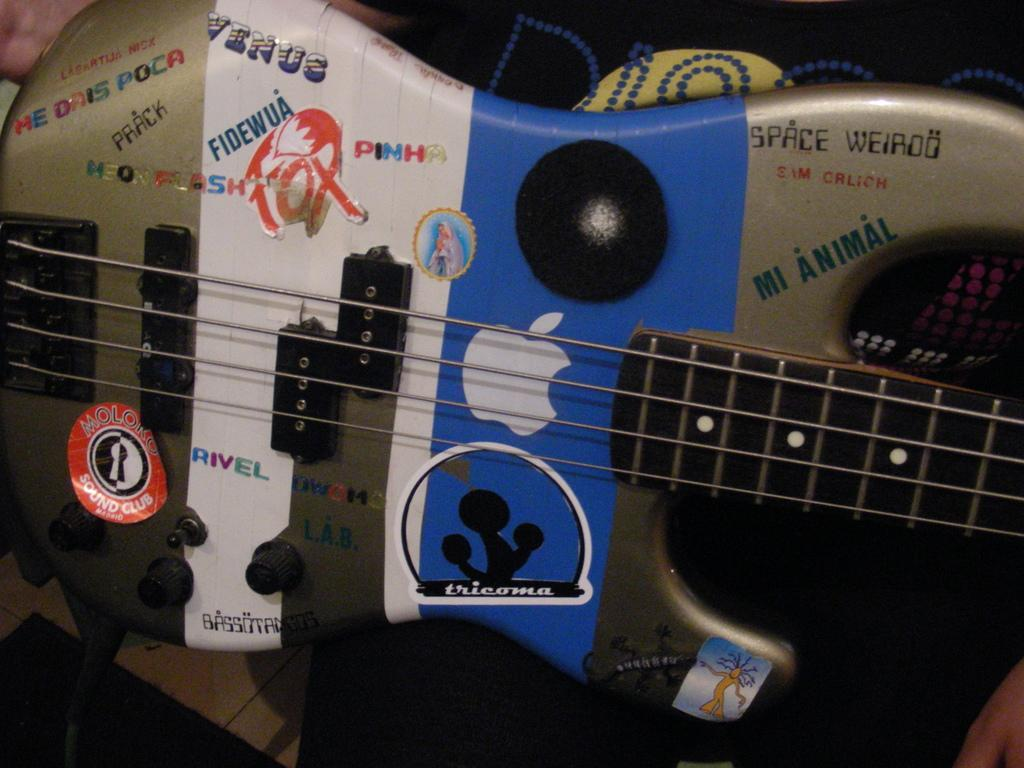What type of object is the main subject of the image? There is a musical instrument in the image. What type of ocean can be seen in the background of the image? There is no ocean present in the image; it features a musical instrument. How does the toothpaste help in playing the musical instrument in the image? There is no toothpaste present in the image, and it is not related to playing a musical instrument. 